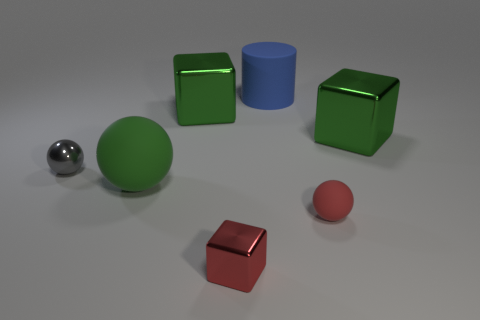What number of things are both in front of the matte cylinder and behind the red ball? There appears to be one such item that meets the criteria of being in front of the matte cylinder and behind the red ball, which is the smaller green cube partially occluded by the red ball. 